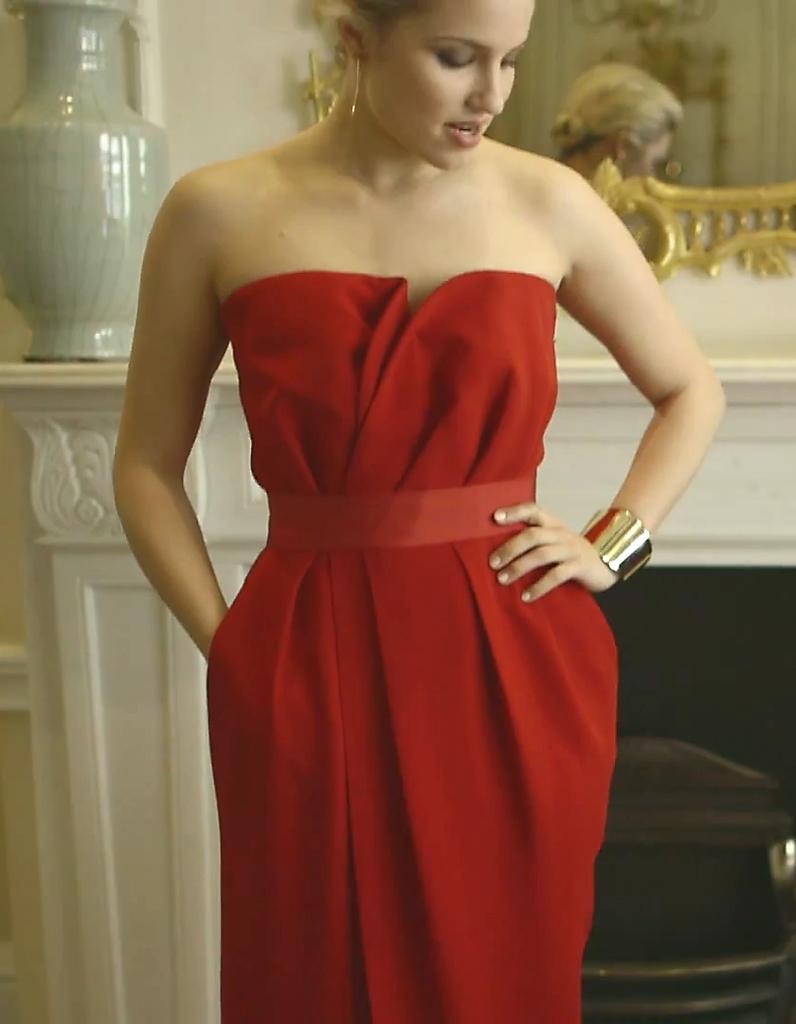Can you describe this image briefly? In this picture I can see a woman standing, there is a vase, there is a mirror attached to the wall and there are some objects. 